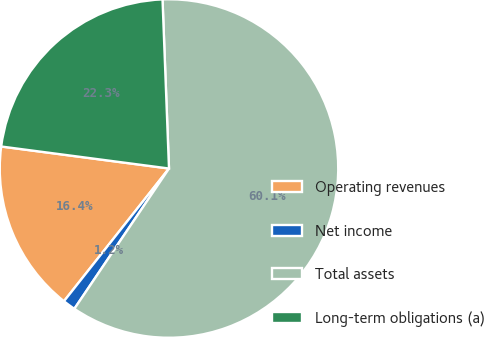Convert chart. <chart><loc_0><loc_0><loc_500><loc_500><pie_chart><fcel>Operating revenues<fcel>Net income<fcel>Total assets<fcel>Long-term obligations (a)<nl><fcel>16.42%<fcel>1.21%<fcel>60.05%<fcel>22.31%<nl></chart> 